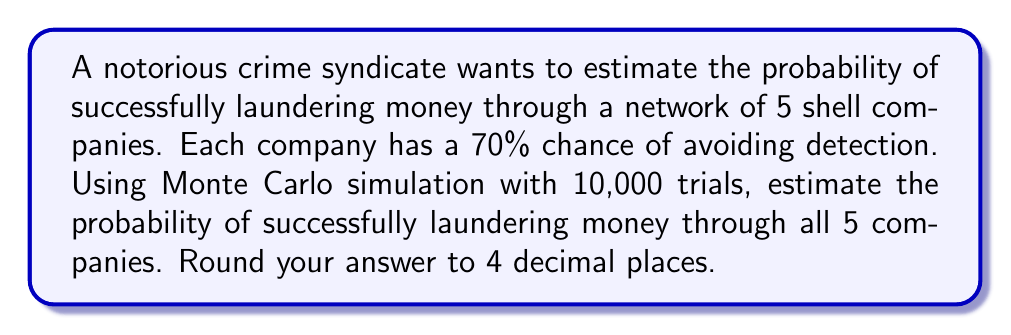Give your solution to this math problem. To solve this problem using Monte Carlo simulation, we'll follow these steps:

1) Set up the simulation:
   - We have 5 shell companies
   - Each company has a 70% chance of avoiding detection
   - We'll run 10,000 trials

2) For each trial:
   - Generate 5 random numbers between 0 and 1
   - If all 5 numbers are ≤ 0.7, consider it a successful laundering attempt

3) Count the number of successful trials

4) Divide the number of successful trials by the total number of trials

Let's implement this in Python:

```python
import random

def simulate_laundering():
    return all(random.random() <= 0.7 for _ in range(5))

trials = 10000
successful_trials = sum(simulate_laundering() for _ in range(trials))

probability = successful_trials / trials
```

5) The theoretical probability can be calculated as:

   $$P(\text{success}) = 0.7^5 = 0.16807$$

6) The Monte Carlo simulation should give a result close to this theoretical probability.

7) Rounding the result to 4 decimal places gives us the final answer.
Answer: 0.1681 